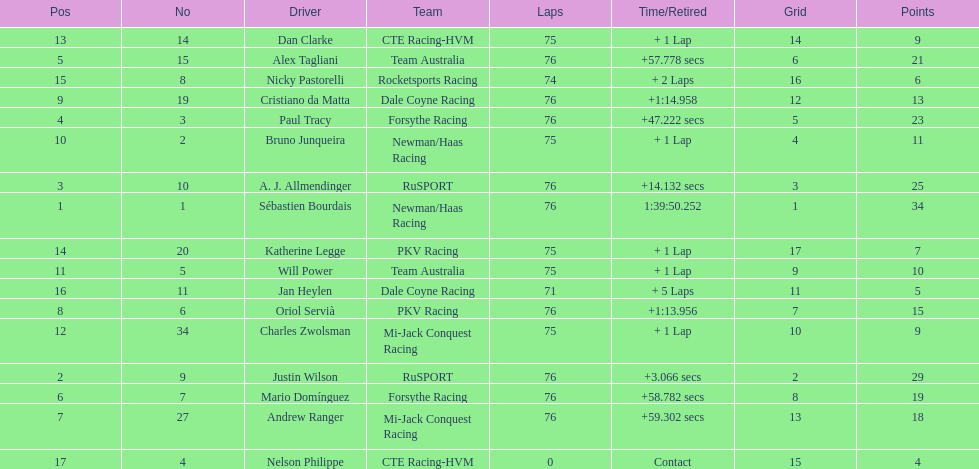What is the total point difference between the driver who received the most points and the driver who received the least? 30. 